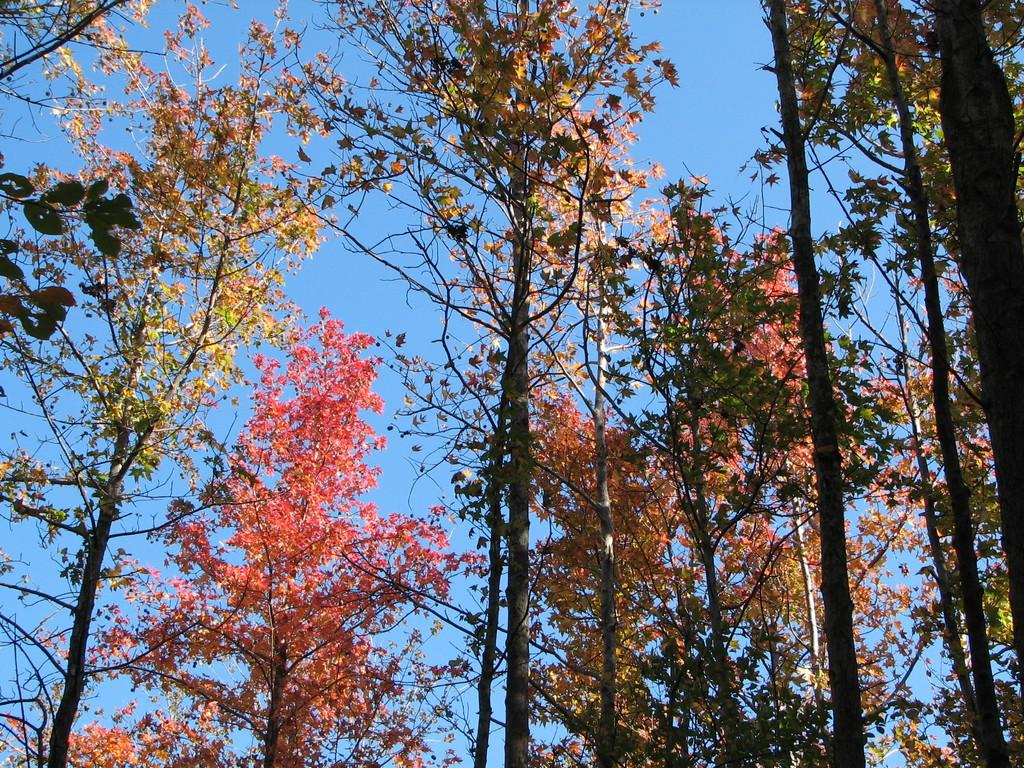What type of vegetation can be seen in the image? There are trees in the image. What part of the natural environment is visible in the image? The sky is visible in the image. What is the color of the sky in the image? The color of the sky is blue. What type of pie is being served by the partner in the image? There is no partner or pie present in the image; it only features trees and a blue sky. 